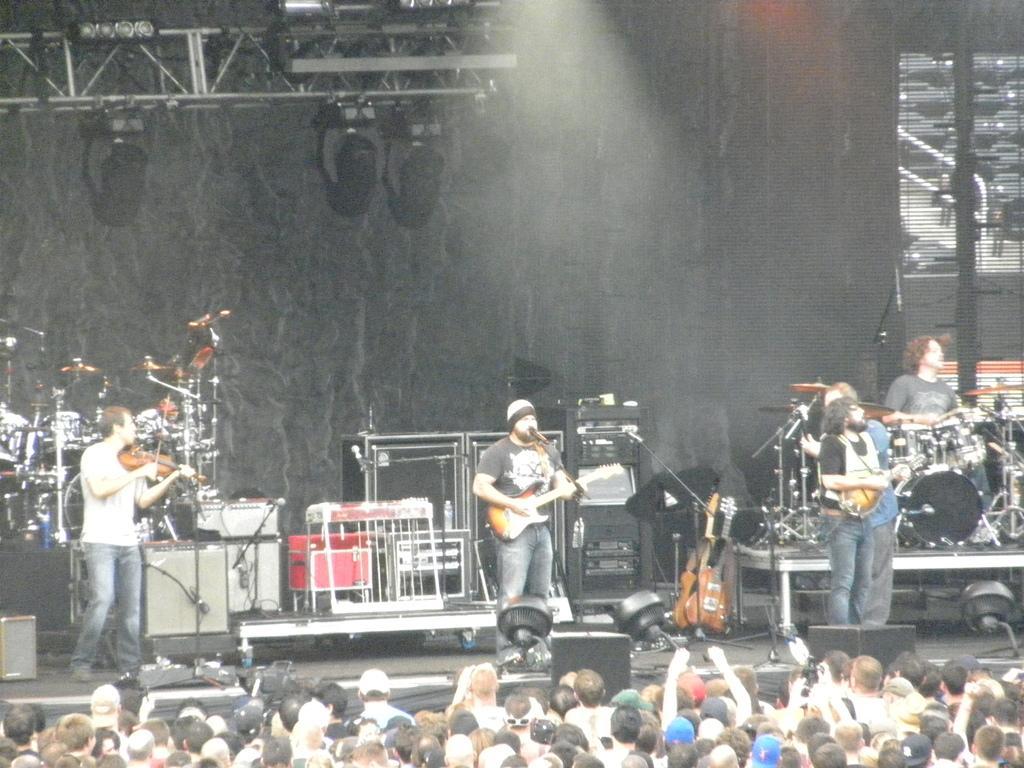Can you describe this image briefly? In this picture we can see crowd of people listening to the music of musicians were in front person is playing guitar and singing song on the mic and on left person is playing violin and on right side person is playing some instrument and in back person is playing drums and at top we can stand with lights. 